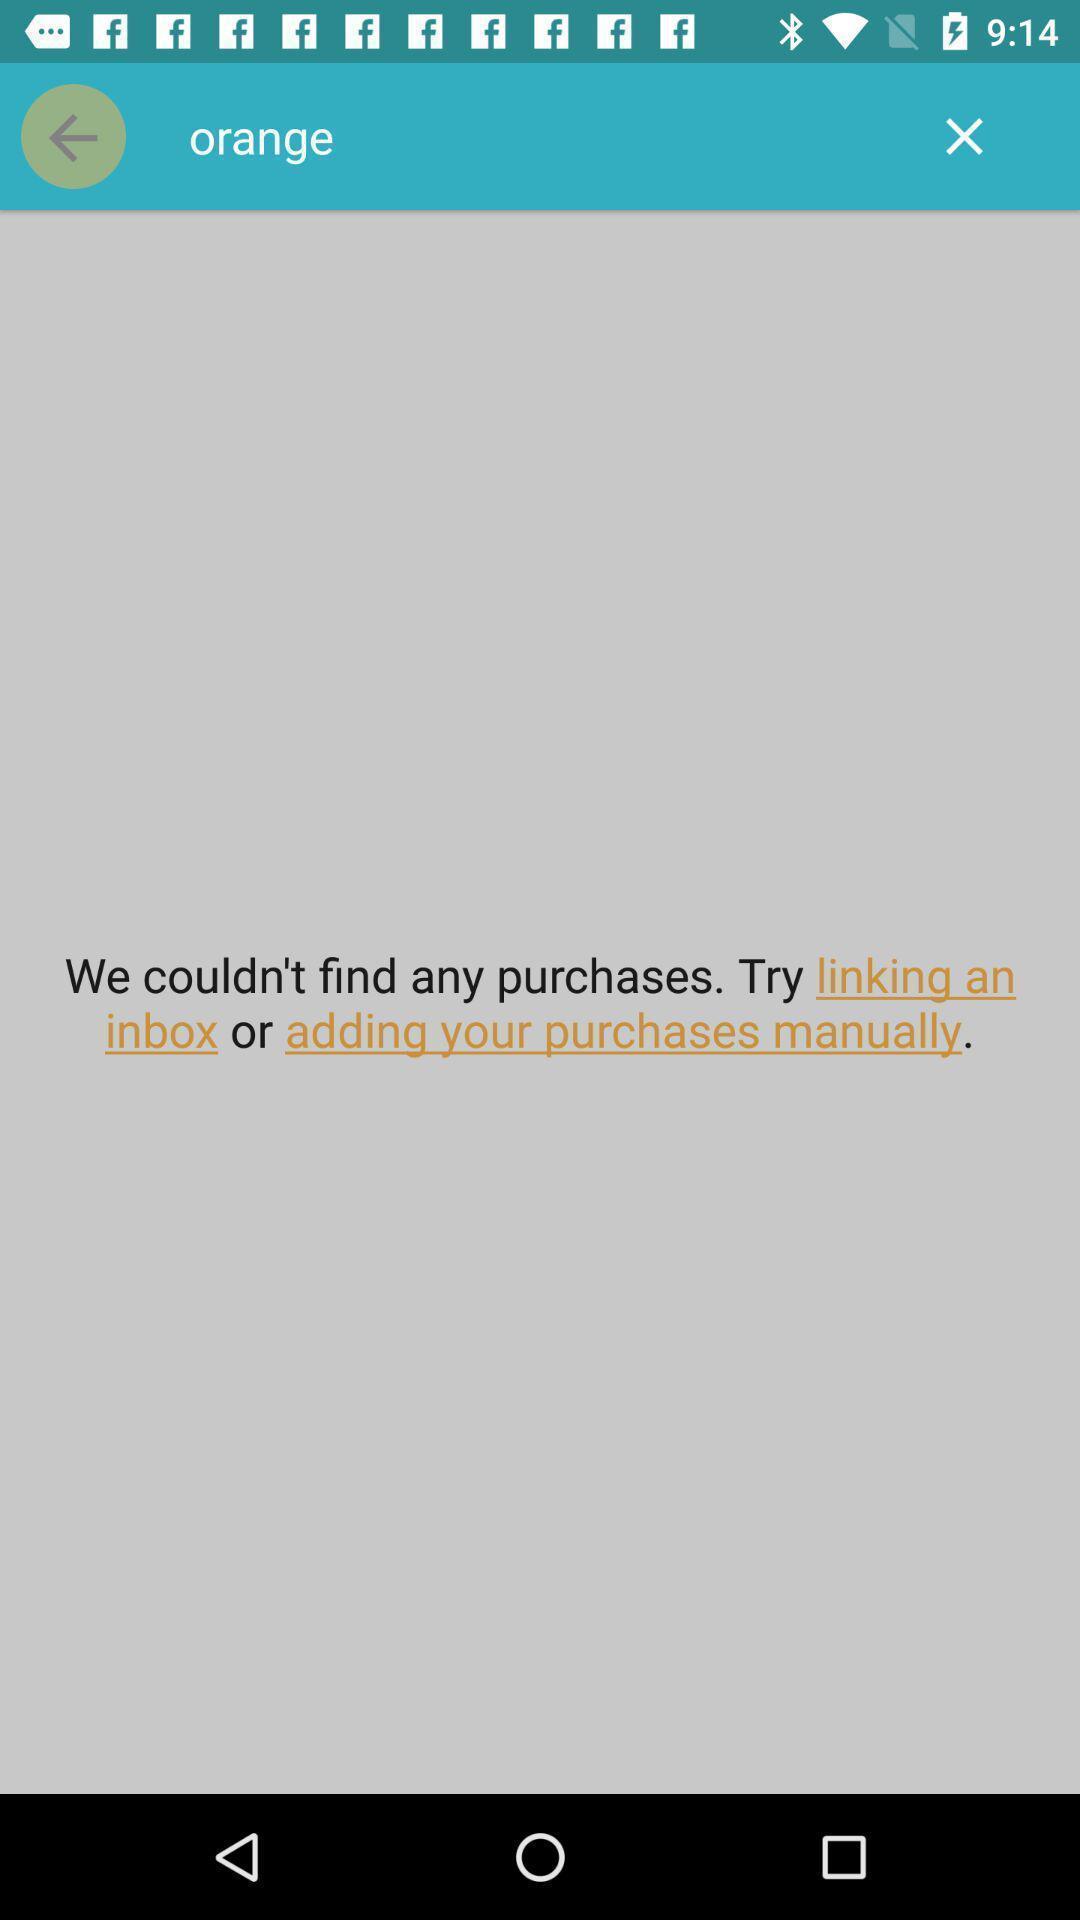What can you discern from this picture? Screen shows orange page in a shopping app. 